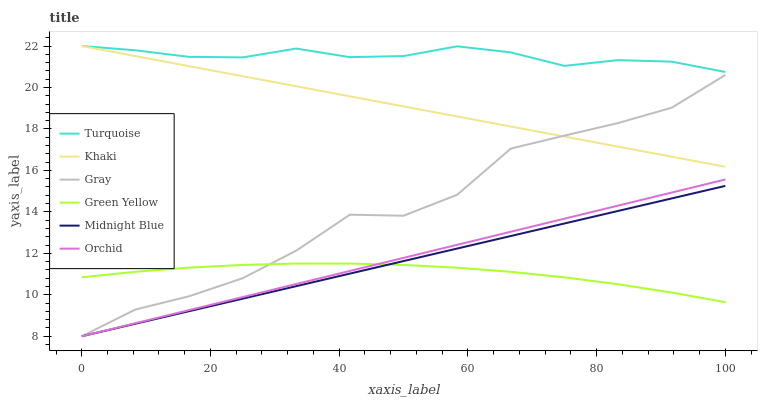Does Green Yellow have the minimum area under the curve?
Answer yes or no. Yes. Does Turquoise have the maximum area under the curve?
Answer yes or no. Yes. Does Khaki have the minimum area under the curve?
Answer yes or no. No. Does Khaki have the maximum area under the curve?
Answer yes or no. No. Is Orchid the smoothest?
Answer yes or no. Yes. Is Gray the roughest?
Answer yes or no. Yes. Is Turquoise the smoothest?
Answer yes or no. No. Is Turquoise the roughest?
Answer yes or no. No. Does Gray have the lowest value?
Answer yes or no. Yes. Does Khaki have the lowest value?
Answer yes or no. No. Does Khaki have the highest value?
Answer yes or no. Yes. Does Midnight Blue have the highest value?
Answer yes or no. No. Is Gray less than Turquoise?
Answer yes or no. Yes. Is Khaki greater than Midnight Blue?
Answer yes or no. Yes. Does Green Yellow intersect Gray?
Answer yes or no. Yes. Is Green Yellow less than Gray?
Answer yes or no. No. Is Green Yellow greater than Gray?
Answer yes or no. No. Does Gray intersect Turquoise?
Answer yes or no. No. 